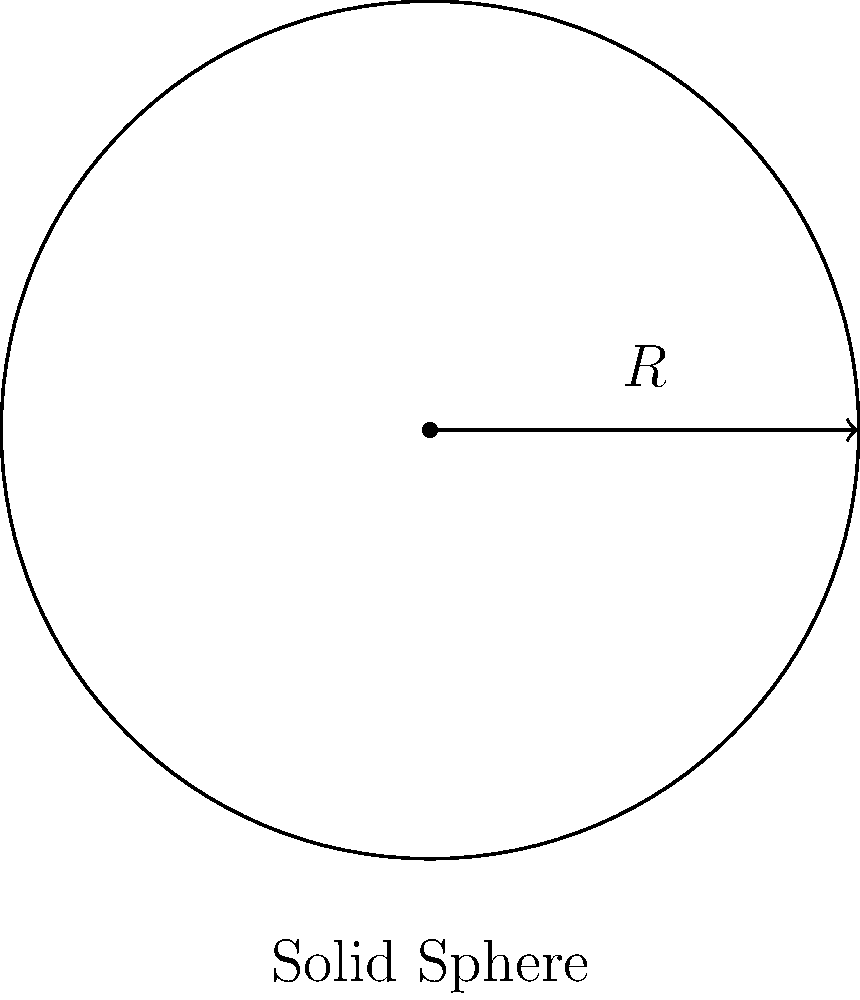Calculate the moment of inertia for a solid sphere with a radius of 5 cm and a mass of 2 kg. Use the formula $I = \frac{2}{5}mR^2$, where $m$ is the mass and $R$ is the radius. To calculate the moment of inertia for a solid sphere, we'll use the given formula and follow these steps:

1. Identify the given values:
   - Radius ($R$) = 5 cm = 0.05 m
   - Mass ($m$) = 2 kg

2. Substitute these values into the formula $I = \frac{2}{5}mR^2$:
   $I = \frac{2}{5} \times 2 \text{ kg} \times (0.05 \text{ m})^2$

3. Calculate the square of the radius:
   $(0.05 \text{ m})^2 = 0.0025 \text{ m}^2$

4. Multiply all the terms:
   $I = \frac{2}{5} \times 2 \text{ kg} \times 0.0025 \text{ m}^2$
   $I = 0.002 \text{ kg} \cdot \text{m}^2$

5. The final answer is 0.002 kg·m².
Answer: $0.002 \text{ kg} \cdot \text{m}^2$ 